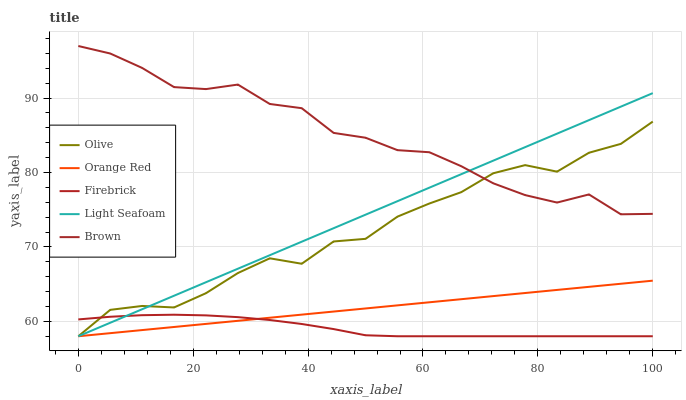Does Firebrick have the minimum area under the curve?
Answer yes or no. Yes. Does Brown have the maximum area under the curve?
Answer yes or no. Yes. Does Brown have the minimum area under the curve?
Answer yes or no. No. Does Firebrick have the maximum area under the curve?
Answer yes or no. No. Is Light Seafoam the smoothest?
Answer yes or no. Yes. Is Olive the roughest?
Answer yes or no. Yes. Is Brown the smoothest?
Answer yes or no. No. Is Brown the roughest?
Answer yes or no. No. Does Olive have the lowest value?
Answer yes or no. Yes. Does Brown have the lowest value?
Answer yes or no. No. Does Brown have the highest value?
Answer yes or no. Yes. Does Firebrick have the highest value?
Answer yes or no. No. Is Orange Red less than Brown?
Answer yes or no. Yes. Is Brown greater than Firebrick?
Answer yes or no. Yes. Does Brown intersect Light Seafoam?
Answer yes or no. Yes. Is Brown less than Light Seafoam?
Answer yes or no. No. Is Brown greater than Light Seafoam?
Answer yes or no. No. Does Orange Red intersect Brown?
Answer yes or no. No. 